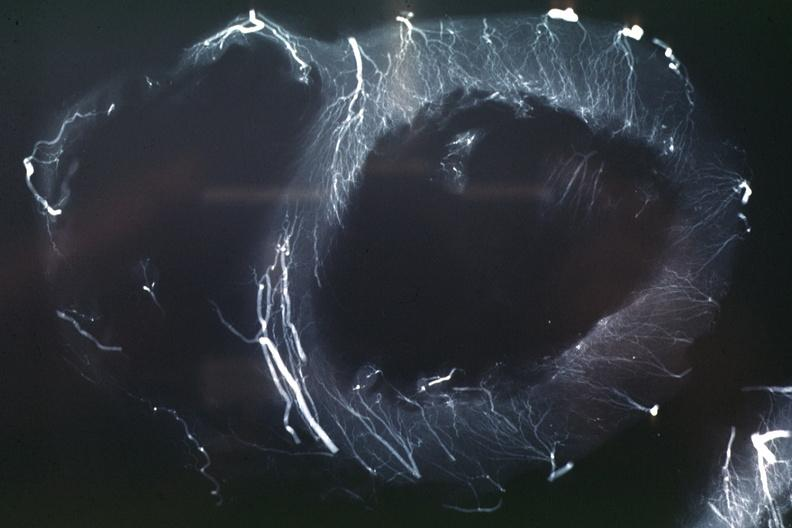s acid present?
Answer the question using a single word or phrase. No 